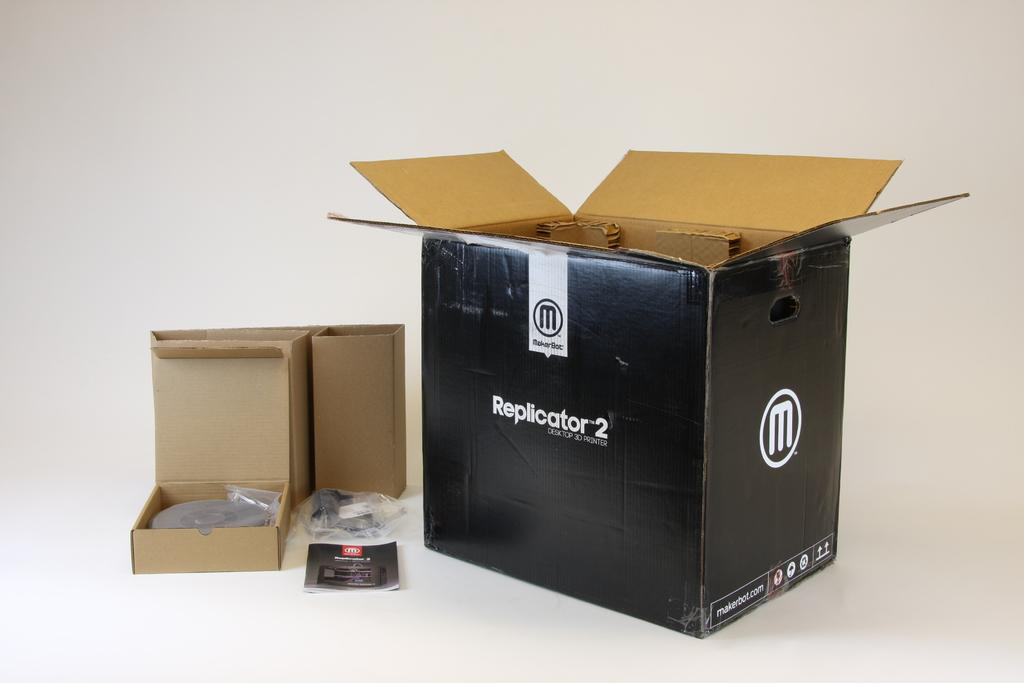<image>
Share a concise interpretation of the image provided. An open Replicator 2 box and its components. 